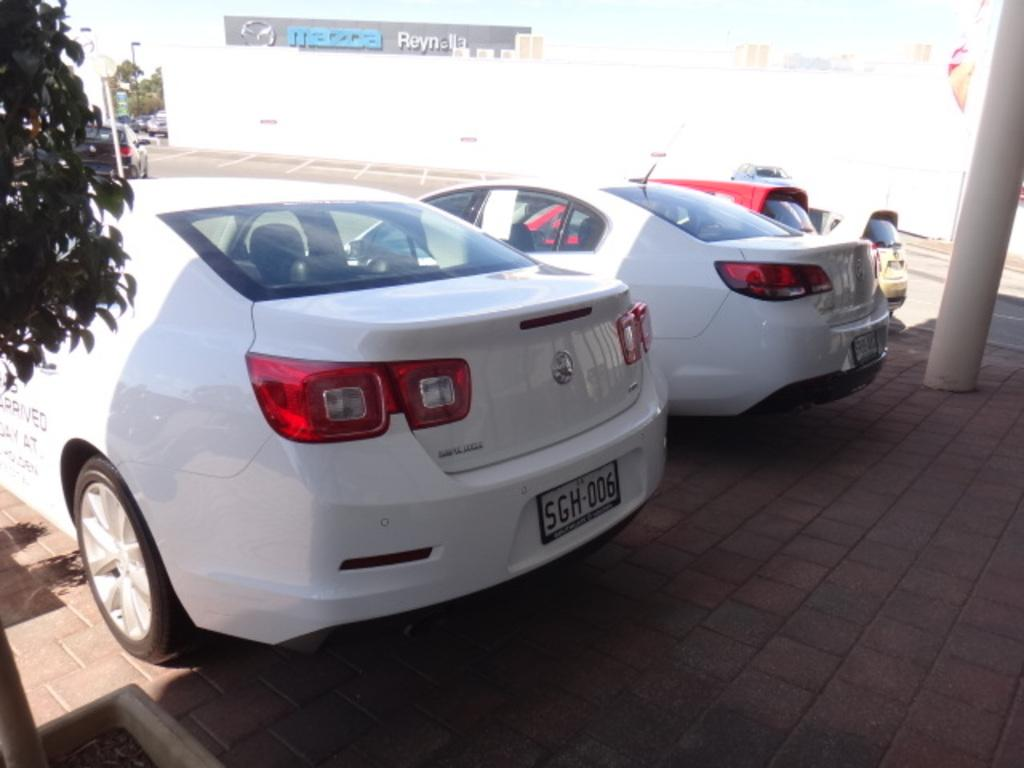<image>
Present a compact description of the photo's key features. TWO WHITE SEDANS PARKED REAR END IN ON A BRICK PAVEMENT 